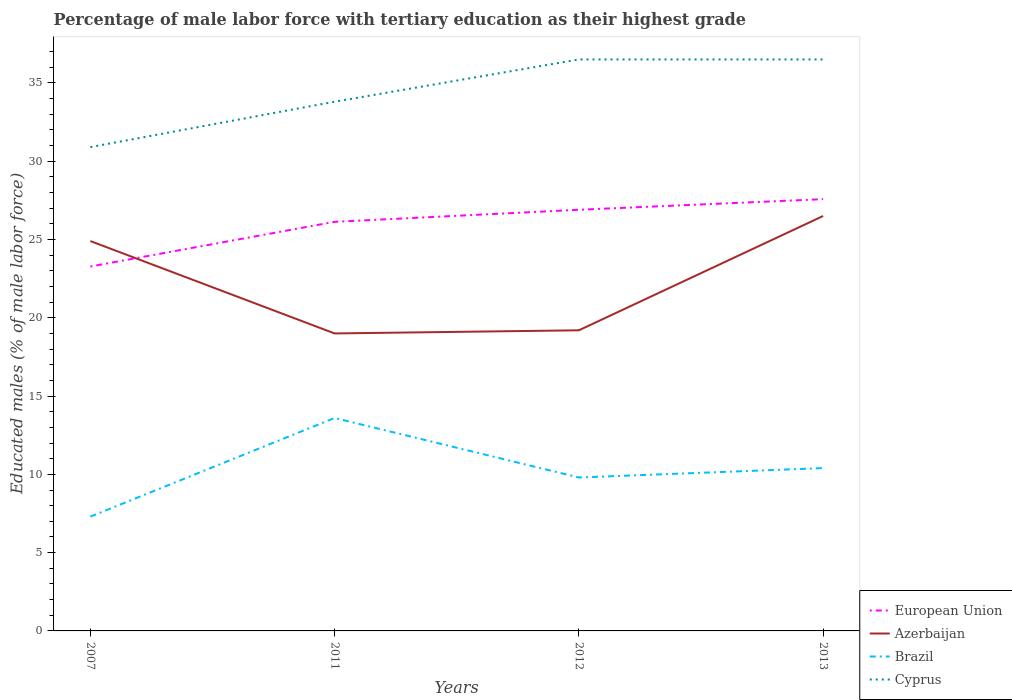Across all years, what is the maximum percentage of male labor force with tertiary education in Cyprus?
Keep it short and to the point. 30.9. What is the total percentage of male labor force with tertiary education in Brazil in the graph?
Provide a short and direct response. -0.6. What is the difference between the highest and the second highest percentage of male labor force with tertiary education in Cyprus?
Your answer should be compact. 5.6. What is the difference between the highest and the lowest percentage of male labor force with tertiary education in Brazil?
Your response must be concise. 2. How many lines are there?
Make the answer very short. 4. Does the graph contain any zero values?
Your answer should be compact. No. Does the graph contain grids?
Provide a succinct answer. No. What is the title of the graph?
Your answer should be compact. Percentage of male labor force with tertiary education as their highest grade. Does "Mexico" appear as one of the legend labels in the graph?
Offer a very short reply. No. What is the label or title of the X-axis?
Make the answer very short. Years. What is the label or title of the Y-axis?
Keep it short and to the point. Educated males (% of male labor force). What is the Educated males (% of male labor force) in European Union in 2007?
Make the answer very short. 23.27. What is the Educated males (% of male labor force) in Azerbaijan in 2007?
Your response must be concise. 24.9. What is the Educated males (% of male labor force) in Brazil in 2007?
Your response must be concise. 7.3. What is the Educated males (% of male labor force) in Cyprus in 2007?
Keep it short and to the point. 30.9. What is the Educated males (% of male labor force) of European Union in 2011?
Your answer should be very brief. 26.13. What is the Educated males (% of male labor force) in Azerbaijan in 2011?
Make the answer very short. 19. What is the Educated males (% of male labor force) of Brazil in 2011?
Provide a short and direct response. 13.6. What is the Educated males (% of male labor force) in Cyprus in 2011?
Provide a succinct answer. 33.8. What is the Educated males (% of male labor force) of European Union in 2012?
Your response must be concise. 26.9. What is the Educated males (% of male labor force) in Azerbaijan in 2012?
Offer a terse response. 19.2. What is the Educated males (% of male labor force) of Brazil in 2012?
Your response must be concise. 9.8. What is the Educated males (% of male labor force) in Cyprus in 2012?
Offer a very short reply. 36.5. What is the Educated males (% of male labor force) in European Union in 2013?
Provide a succinct answer. 27.58. What is the Educated males (% of male labor force) of Azerbaijan in 2013?
Provide a short and direct response. 26.5. What is the Educated males (% of male labor force) of Brazil in 2013?
Offer a terse response. 10.4. What is the Educated males (% of male labor force) of Cyprus in 2013?
Your answer should be very brief. 36.5. Across all years, what is the maximum Educated males (% of male labor force) of European Union?
Your response must be concise. 27.58. Across all years, what is the maximum Educated males (% of male labor force) in Brazil?
Your answer should be very brief. 13.6. Across all years, what is the maximum Educated males (% of male labor force) of Cyprus?
Offer a terse response. 36.5. Across all years, what is the minimum Educated males (% of male labor force) in European Union?
Your answer should be very brief. 23.27. Across all years, what is the minimum Educated males (% of male labor force) of Brazil?
Your answer should be very brief. 7.3. Across all years, what is the minimum Educated males (% of male labor force) of Cyprus?
Keep it short and to the point. 30.9. What is the total Educated males (% of male labor force) of European Union in the graph?
Offer a terse response. 103.88. What is the total Educated males (% of male labor force) in Azerbaijan in the graph?
Offer a very short reply. 89.6. What is the total Educated males (% of male labor force) of Brazil in the graph?
Make the answer very short. 41.1. What is the total Educated males (% of male labor force) of Cyprus in the graph?
Ensure brevity in your answer.  137.7. What is the difference between the Educated males (% of male labor force) in European Union in 2007 and that in 2011?
Give a very brief answer. -2.85. What is the difference between the Educated males (% of male labor force) in Azerbaijan in 2007 and that in 2011?
Provide a short and direct response. 5.9. What is the difference between the Educated males (% of male labor force) of Brazil in 2007 and that in 2011?
Give a very brief answer. -6.3. What is the difference between the Educated males (% of male labor force) in European Union in 2007 and that in 2012?
Keep it short and to the point. -3.62. What is the difference between the Educated males (% of male labor force) of European Union in 2007 and that in 2013?
Make the answer very short. -4.3. What is the difference between the Educated males (% of male labor force) of Brazil in 2007 and that in 2013?
Keep it short and to the point. -3.1. What is the difference between the Educated males (% of male labor force) in Cyprus in 2007 and that in 2013?
Keep it short and to the point. -5.6. What is the difference between the Educated males (% of male labor force) of European Union in 2011 and that in 2012?
Offer a very short reply. -0.77. What is the difference between the Educated males (% of male labor force) in Brazil in 2011 and that in 2012?
Keep it short and to the point. 3.8. What is the difference between the Educated males (% of male labor force) of European Union in 2011 and that in 2013?
Your answer should be very brief. -1.45. What is the difference between the Educated males (% of male labor force) in European Union in 2012 and that in 2013?
Provide a succinct answer. -0.68. What is the difference between the Educated males (% of male labor force) in Azerbaijan in 2012 and that in 2013?
Offer a terse response. -7.3. What is the difference between the Educated males (% of male labor force) in European Union in 2007 and the Educated males (% of male labor force) in Azerbaijan in 2011?
Keep it short and to the point. 4.27. What is the difference between the Educated males (% of male labor force) of European Union in 2007 and the Educated males (% of male labor force) of Brazil in 2011?
Make the answer very short. 9.67. What is the difference between the Educated males (% of male labor force) in European Union in 2007 and the Educated males (% of male labor force) in Cyprus in 2011?
Your response must be concise. -10.53. What is the difference between the Educated males (% of male labor force) of Azerbaijan in 2007 and the Educated males (% of male labor force) of Cyprus in 2011?
Provide a short and direct response. -8.9. What is the difference between the Educated males (% of male labor force) of Brazil in 2007 and the Educated males (% of male labor force) of Cyprus in 2011?
Your response must be concise. -26.5. What is the difference between the Educated males (% of male labor force) of European Union in 2007 and the Educated males (% of male labor force) of Azerbaijan in 2012?
Ensure brevity in your answer.  4.07. What is the difference between the Educated males (% of male labor force) in European Union in 2007 and the Educated males (% of male labor force) in Brazil in 2012?
Offer a terse response. 13.47. What is the difference between the Educated males (% of male labor force) in European Union in 2007 and the Educated males (% of male labor force) in Cyprus in 2012?
Your answer should be compact. -13.23. What is the difference between the Educated males (% of male labor force) of Azerbaijan in 2007 and the Educated males (% of male labor force) of Cyprus in 2012?
Make the answer very short. -11.6. What is the difference between the Educated males (% of male labor force) of Brazil in 2007 and the Educated males (% of male labor force) of Cyprus in 2012?
Your answer should be compact. -29.2. What is the difference between the Educated males (% of male labor force) of European Union in 2007 and the Educated males (% of male labor force) of Azerbaijan in 2013?
Your answer should be compact. -3.23. What is the difference between the Educated males (% of male labor force) of European Union in 2007 and the Educated males (% of male labor force) of Brazil in 2013?
Provide a succinct answer. 12.87. What is the difference between the Educated males (% of male labor force) in European Union in 2007 and the Educated males (% of male labor force) in Cyprus in 2013?
Provide a short and direct response. -13.23. What is the difference between the Educated males (% of male labor force) in Azerbaijan in 2007 and the Educated males (% of male labor force) in Brazil in 2013?
Provide a short and direct response. 14.5. What is the difference between the Educated males (% of male labor force) of Azerbaijan in 2007 and the Educated males (% of male labor force) of Cyprus in 2013?
Ensure brevity in your answer.  -11.6. What is the difference between the Educated males (% of male labor force) of Brazil in 2007 and the Educated males (% of male labor force) of Cyprus in 2013?
Your response must be concise. -29.2. What is the difference between the Educated males (% of male labor force) of European Union in 2011 and the Educated males (% of male labor force) of Azerbaijan in 2012?
Make the answer very short. 6.93. What is the difference between the Educated males (% of male labor force) in European Union in 2011 and the Educated males (% of male labor force) in Brazil in 2012?
Your answer should be very brief. 16.33. What is the difference between the Educated males (% of male labor force) in European Union in 2011 and the Educated males (% of male labor force) in Cyprus in 2012?
Ensure brevity in your answer.  -10.37. What is the difference between the Educated males (% of male labor force) of Azerbaijan in 2011 and the Educated males (% of male labor force) of Cyprus in 2012?
Your answer should be compact. -17.5. What is the difference between the Educated males (% of male labor force) of Brazil in 2011 and the Educated males (% of male labor force) of Cyprus in 2012?
Ensure brevity in your answer.  -22.9. What is the difference between the Educated males (% of male labor force) of European Union in 2011 and the Educated males (% of male labor force) of Azerbaijan in 2013?
Make the answer very short. -0.37. What is the difference between the Educated males (% of male labor force) of European Union in 2011 and the Educated males (% of male labor force) of Brazil in 2013?
Ensure brevity in your answer.  15.73. What is the difference between the Educated males (% of male labor force) of European Union in 2011 and the Educated males (% of male labor force) of Cyprus in 2013?
Your response must be concise. -10.37. What is the difference between the Educated males (% of male labor force) of Azerbaijan in 2011 and the Educated males (% of male labor force) of Brazil in 2013?
Make the answer very short. 8.6. What is the difference between the Educated males (% of male labor force) of Azerbaijan in 2011 and the Educated males (% of male labor force) of Cyprus in 2013?
Make the answer very short. -17.5. What is the difference between the Educated males (% of male labor force) in Brazil in 2011 and the Educated males (% of male labor force) in Cyprus in 2013?
Give a very brief answer. -22.9. What is the difference between the Educated males (% of male labor force) in European Union in 2012 and the Educated males (% of male labor force) in Azerbaijan in 2013?
Offer a very short reply. 0.4. What is the difference between the Educated males (% of male labor force) of European Union in 2012 and the Educated males (% of male labor force) of Brazil in 2013?
Your answer should be very brief. 16.5. What is the difference between the Educated males (% of male labor force) of European Union in 2012 and the Educated males (% of male labor force) of Cyprus in 2013?
Your answer should be compact. -9.6. What is the difference between the Educated males (% of male labor force) in Azerbaijan in 2012 and the Educated males (% of male labor force) in Brazil in 2013?
Your response must be concise. 8.8. What is the difference between the Educated males (% of male labor force) of Azerbaijan in 2012 and the Educated males (% of male labor force) of Cyprus in 2013?
Provide a short and direct response. -17.3. What is the difference between the Educated males (% of male labor force) in Brazil in 2012 and the Educated males (% of male labor force) in Cyprus in 2013?
Offer a terse response. -26.7. What is the average Educated males (% of male labor force) of European Union per year?
Provide a succinct answer. 25.97. What is the average Educated males (% of male labor force) in Azerbaijan per year?
Your answer should be compact. 22.4. What is the average Educated males (% of male labor force) of Brazil per year?
Ensure brevity in your answer.  10.28. What is the average Educated males (% of male labor force) in Cyprus per year?
Offer a very short reply. 34.42. In the year 2007, what is the difference between the Educated males (% of male labor force) in European Union and Educated males (% of male labor force) in Azerbaijan?
Provide a succinct answer. -1.63. In the year 2007, what is the difference between the Educated males (% of male labor force) of European Union and Educated males (% of male labor force) of Brazil?
Give a very brief answer. 15.97. In the year 2007, what is the difference between the Educated males (% of male labor force) of European Union and Educated males (% of male labor force) of Cyprus?
Give a very brief answer. -7.63. In the year 2007, what is the difference between the Educated males (% of male labor force) in Azerbaijan and Educated males (% of male labor force) in Brazil?
Your answer should be very brief. 17.6. In the year 2007, what is the difference between the Educated males (% of male labor force) in Azerbaijan and Educated males (% of male labor force) in Cyprus?
Your answer should be very brief. -6. In the year 2007, what is the difference between the Educated males (% of male labor force) in Brazil and Educated males (% of male labor force) in Cyprus?
Ensure brevity in your answer.  -23.6. In the year 2011, what is the difference between the Educated males (% of male labor force) of European Union and Educated males (% of male labor force) of Azerbaijan?
Offer a very short reply. 7.13. In the year 2011, what is the difference between the Educated males (% of male labor force) in European Union and Educated males (% of male labor force) in Brazil?
Make the answer very short. 12.53. In the year 2011, what is the difference between the Educated males (% of male labor force) in European Union and Educated males (% of male labor force) in Cyprus?
Give a very brief answer. -7.67. In the year 2011, what is the difference between the Educated males (% of male labor force) in Azerbaijan and Educated males (% of male labor force) in Brazil?
Keep it short and to the point. 5.4. In the year 2011, what is the difference between the Educated males (% of male labor force) of Azerbaijan and Educated males (% of male labor force) of Cyprus?
Offer a terse response. -14.8. In the year 2011, what is the difference between the Educated males (% of male labor force) of Brazil and Educated males (% of male labor force) of Cyprus?
Offer a terse response. -20.2. In the year 2012, what is the difference between the Educated males (% of male labor force) of European Union and Educated males (% of male labor force) of Azerbaijan?
Give a very brief answer. 7.7. In the year 2012, what is the difference between the Educated males (% of male labor force) of European Union and Educated males (% of male labor force) of Brazil?
Your answer should be compact. 17.1. In the year 2012, what is the difference between the Educated males (% of male labor force) of European Union and Educated males (% of male labor force) of Cyprus?
Your answer should be very brief. -9.6. In the year 2012, what is the difference between the Educated males (% of male labor force) of Azerbaijan and Educated males (% of male labor force) of Cyprus?
Offer a terse response. -17.3. In the year 2012, what is the difference between the Educated males (% of male labor force) of Brazil and Educated males (% of male labor force) of Cyprus?
Ensure brevity in your answer.  -26.7. In the year 2013, what is the difference between the Educated males (% of male labor force) of European Union and Educated males (% of male labor force) of Azerbaijan?
Ensure brevity in your answer.  1.08. In the year 2013, what is the difference between the Educated males (% of male labor force) in European Union and Educated males (% of male labor force) in Brazil?
Provide a short and direct response. 17.18. In the year 2013, what is the difference between the Educated males (% of male labor force) in European Union and Educated males (% of male labor force) in Cyprus?
Offer a very short reply. -8.92. In the year 2013, what is the difference between the Educated males (% of male labor force) in Azerbaijan and Educated males (% of male labor force) in Cyprus?
Make the answer very short. -10. In the year 2013, what is the difference between the Educated males (% of male labor force) of Brazil and Educated males (% of male labor force) of Cyprus?
Offer a very short reply. -26.1. What is the ratio of the Educated males (% of male labor force) in European Union in 2007 to that in 2011?
Provide a succinct answer. 0.89. What is the ratio of the Educated males (% of male labor force) of Azerbaijan in 2007 to that in 2011?
Your response must be concise. 1.31. What is the ratio of the Educated males (% of male labor force) of Brazil in 2007 to that in 2011?
Make the answer very short. 0.54. What is the ratio of the Educated males (% of male labor force) in Cyprus in 2007 to that in 2011?
Offer a very short reply. 0.91. What is the ratio of the Educated males (% of male labor force) of European Union in 2007 to that in 2012?
Keep it short and to the point. 0.87. What is the ratio of the Educated males (% of male labor force) of Azerbaijan in 2007 to that in 2012?
Your answer should be compact. 1.3. What is the ratio of the Educated males (% of male labor force) of Brazil in 2007 to that in 2012?
Offer a very short reply. 0.74. What is the ratio of the Educated males (% of male labor force) in Cyprus in 2007 to that in 2012?
Your answer should be compact. 0.85. What is the ratio of the Educated males (% of male labor force) in European Union in 2007 to that in 2013?
Provide a succinct answer. 0.84. What is the ratio of the Educated males (% of male labor force) of Azerbaijan in 2007 to that in 2013?
Provide a short and direct response. 0.94. What is the ratio of the Educated males (% of male labor force) in Brazil in 2007 to that in 2013?
Offer a very short reply. 0.7. What is the ratio of the Educated males (% of male labor force) in Cyprus in 2007 to that in 2013?
Ensure brevity in your answer.  0.85. What is the ratio of the Educated males (% of male labor force) of European Union in 2011 to that in 2012?
Your answer should be very brief. 0.97. What is the ratio of the Educated males (% of male labor force) in Azerbaijan in 2011 to that in 2012?
Make the answer very short. 0.99. What is the ratio of the Educated males (% of male labor force) of Brazil in 2011 to that in 2012?
Offer a terse response. 1.39. What is the ratio of the Educated males (% of male labor force) in Cyprus in 2011 to that in 2012?
Provide a succinct answer. 0.93. What is the ratio of the Educated males (% of male labor force) in European Union in 2011 to that in 2013?
Your response must be concise. 0.95. What is the ratio of the Educated males (% of male labor force) of Azerbaijan in 2011 to that in 2013?
Your response must be concise. 0.72. What is the ratio of the Educated males (% of male labor force) of Brazil in 2011 to that in 2013?
Give a very brief answer. 1.31. What is the ratio of the Educated males (% of male labor force) of Cyprus in 2011 to that in 2013?
Provide a short and direct response. 0.93. What is the ratio of the Educated males (% of male labor force) of European Union in 2012 to that in 2013?
Your answer should be compact. 0.98. What is the ratio of the Educated males (% of male labor force) in Azerbaijan in 2012 to that in 2013?
Provide a succinct answer. 0.72. What is the ratio of the Educated males (% of male labor force) in Brazil in 2012 to that in 2013?
Your response must be concise. 0.94. What is the ratio of the Educated males (% of male labor force) of Cyprus in 2012 to that in 2013?
Keep it short and to the point. 1. What is the difference between the highest and the second highest Educated males (% of male labor force) of European Union?
Ensure brevity in your answer.  0.68. What is the difference between the highest and the second highest Educated males (% of male labor force) in Cyprus?
Keep it short and to the point. 0. What is the difference between the highest and the lowest Educated males (% of male labor force) in European Union?
Provide a succinct answer. 4.3. What is the difference between the highest and the lowest Educated males (% of male labor force) in Cyprus?
Keep it short and to the point. 5.6. 